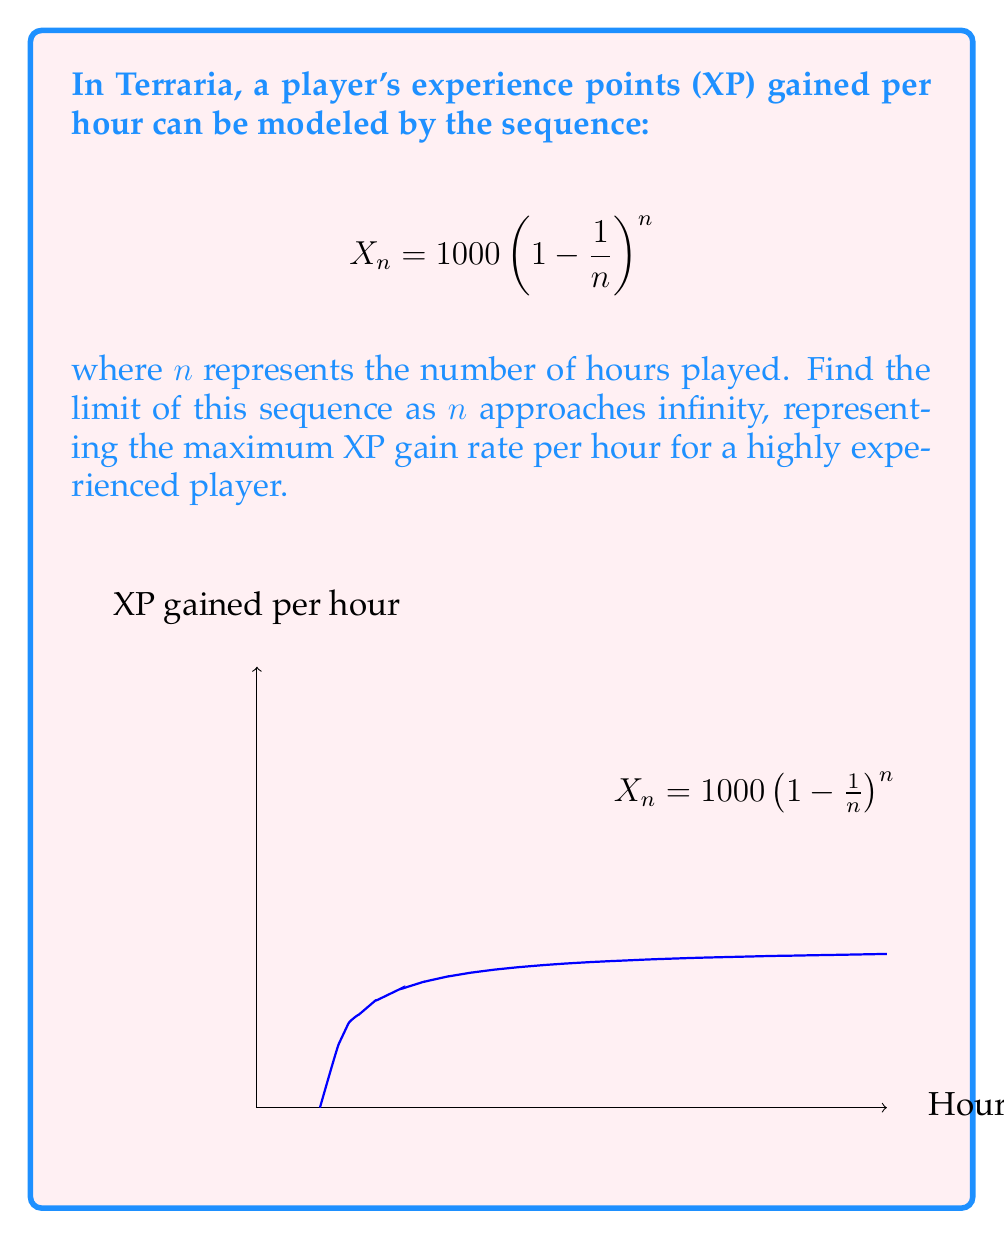What is the answer to this math problem? Let's approach this step-by-step:

1) We need to find $\lim_{n \to \infty} 1000 \left(1 - \frac{1}{n}\right)^n$

2) This limit can be rewritten as:
   $$ 1000 \cdot \lim_{n \to \infty} \left(1 - \frac{1}{n}\right)^n $$

3) The limit $\lim_{n \to \infty} \left(1 - \frac{1}{n}\right)^n$ is a well-known limit that equals $\frac{1}{e}$, where $e$ is Euler's number.

4) We can prove this:
   Let $y = \left(1 - \frac{1}{n}\right)^n$
   Then $\ln y = n \ln\left(1 - \frac{1}{n}\right)$
   
   As $n \to \infty$, we can use the limit definition of $\ln$:
   $$ \lim_{n \to \infty} \ln y = \lim_{n \to \infty} n \ln\left(1 - \frac{1}{n}\right) = \lim_{n \to \infty} \frac{\ln\left(1 - \frac{1}{n}\right)}{\frac{1}{n}} = -1 $$

   Therefore, $\ln y = -1$, or $y = e^{-1} = \frac{1}{e}$

5) Substituting this back into our original limit:
   $$ \lim_{n \to \infty} 1000 \left(1 - \frac{1}{n}\right)^n = 1000 \cdot \frac{1}{e} $$

6) Simplifying:
   $$ \frac{1000}{e} \approx 367.879 $$

This means that as a player's experience in Terraria grows infinitely, their XP gain rate approaches approximately 367.879 XP per hour.
Answer: $\frac{1000}{e}$ 